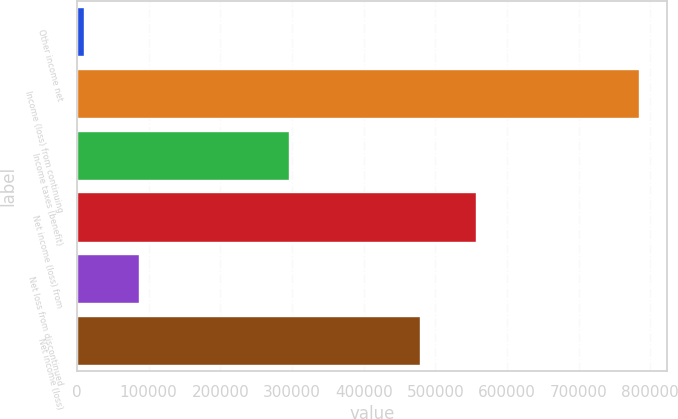Convert chart. <chart><loc_0><loc_0><loc_500><loc_500><bar_chart><fcel>Other income net<fcel>Income (loss) from continuing<fcel>Income taxes (benefit)<fcel>Net income (loss) from<fcel>Net loss from discontinued<fcel>Net income (loss)<nl><fcel>9298<fcel>784135<fcel>295189<fcel>556726<fcel>86781.7<fcel>479242<nl></chart> 